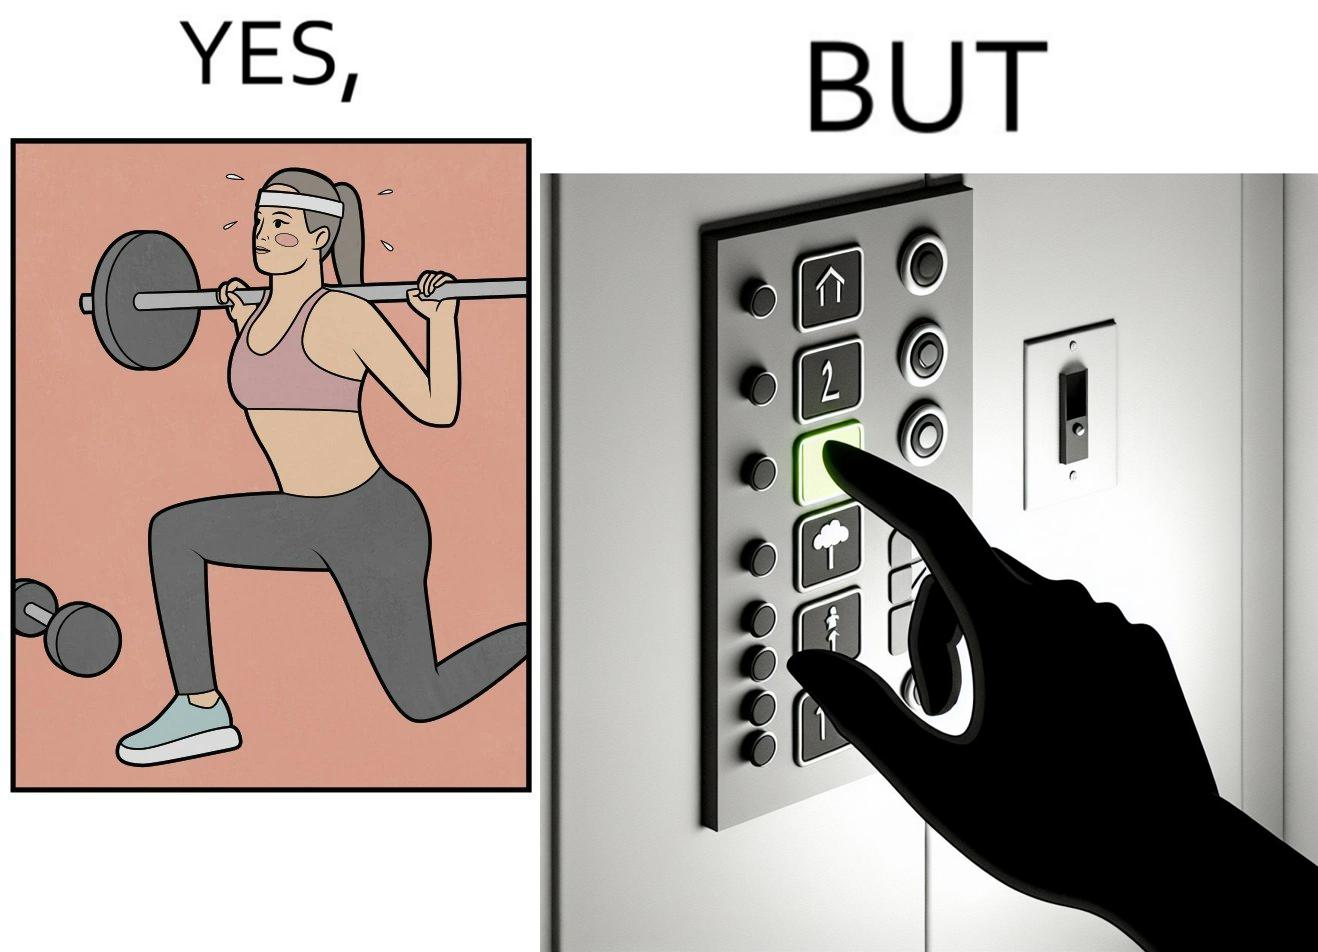Explain the humor or irony in this image. The image is satirical because it shows that while people do various kinds of exercises and go to gym to stay fit, they avoid doing simplest of physical tasks like using stairs instead of elevators to get to even the first or the second floor of a building. 